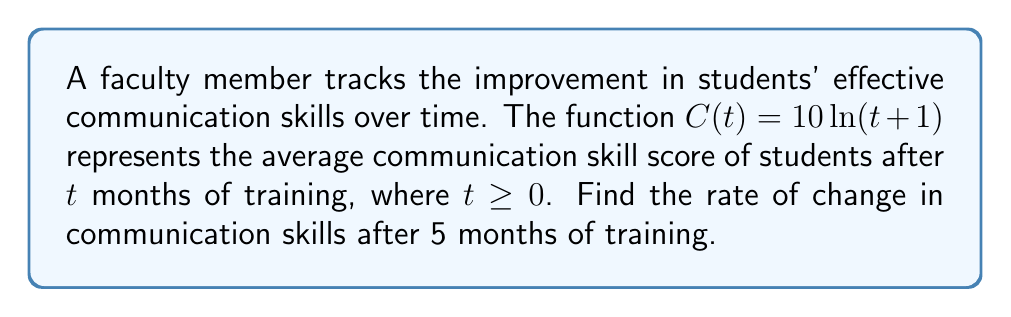Show me your answer to this math problem. To find the rate of change in communication skills after 5 months, we need to calculate the derivative of $C(t)$ and evaluate it at $t=5$.

Step 1: Find the derivative of $C(t)$.
$C(t) = 10\ln(t+1)$
$\frac{d}{dt}[C(t)] = \frac{d}{dt}[10\ln(t+1)]$
Using the chain rule:
$C'(t) = 10 \cdot \frac{1}{t+1} \cdot \frac{d}{dt}[t+1]$
$C'(t) = 10 \cdot \frac{1}{t+1} \cdot 1$
$C'(t) = \frac{10}{t+1}$

Step 2: Evaluate $C'(t)$ at $t=5$.
$C'(5) = \frac{10}{5+1} = \frac{10}{6} = \frac{5}{3}$

Therefore, the rate of change in communication skills after 5 months of training is $\frac{5}{3}$ points per month.
Answer: $\frac{5}{3}$ points/month 